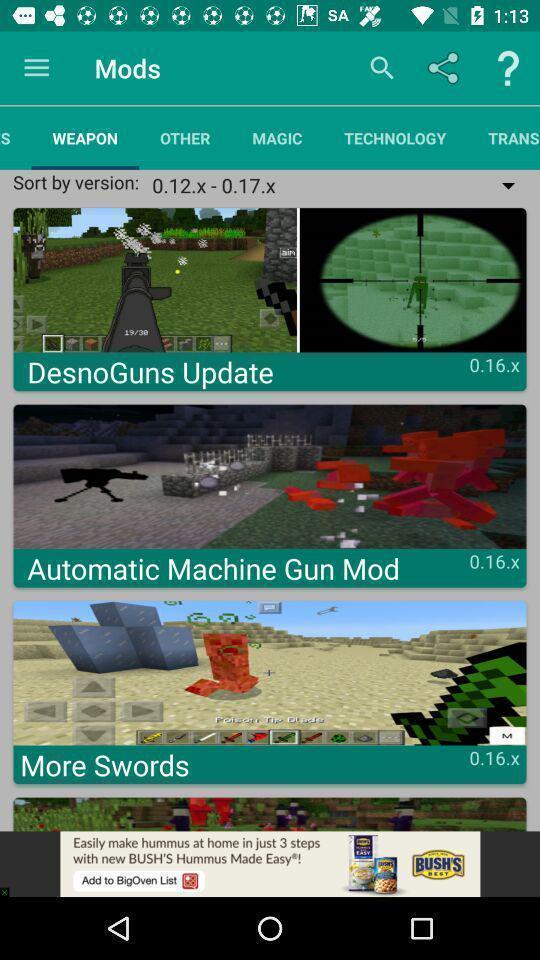What can you discern from this picture? Page showing various options from a gaming app. 